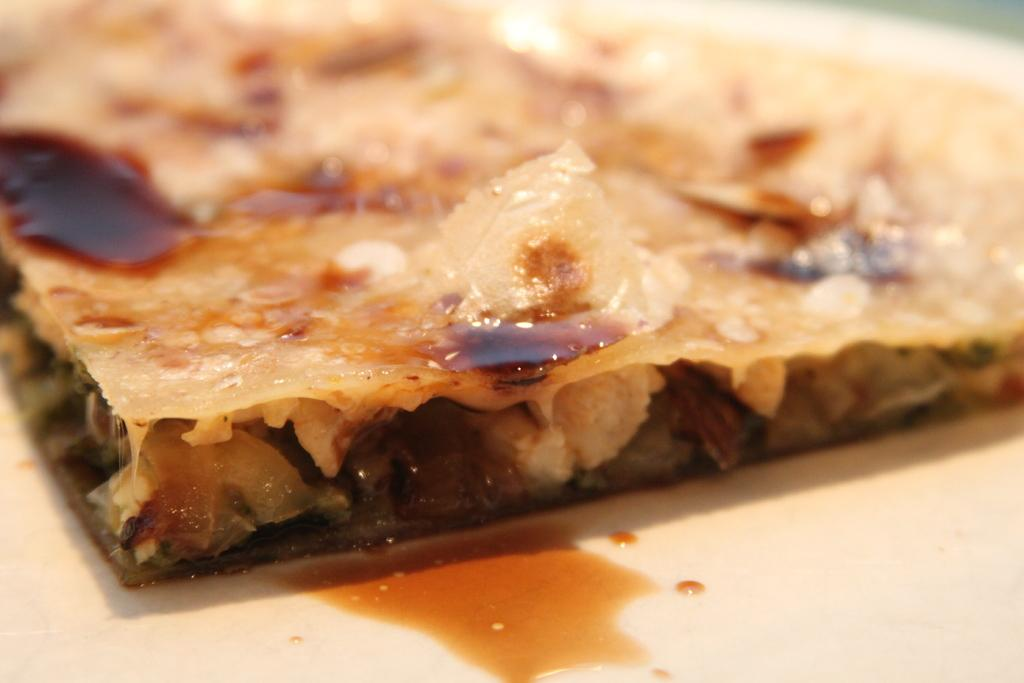What is on the plate that is visible in the image? There is a plate containing food in the image. What type of brake can be seen on the plate in the image? There is no brake present on the plate in the image; it contains food. How is the glue being used in the image? There is no glue present in the image; it features a plate containing food. 